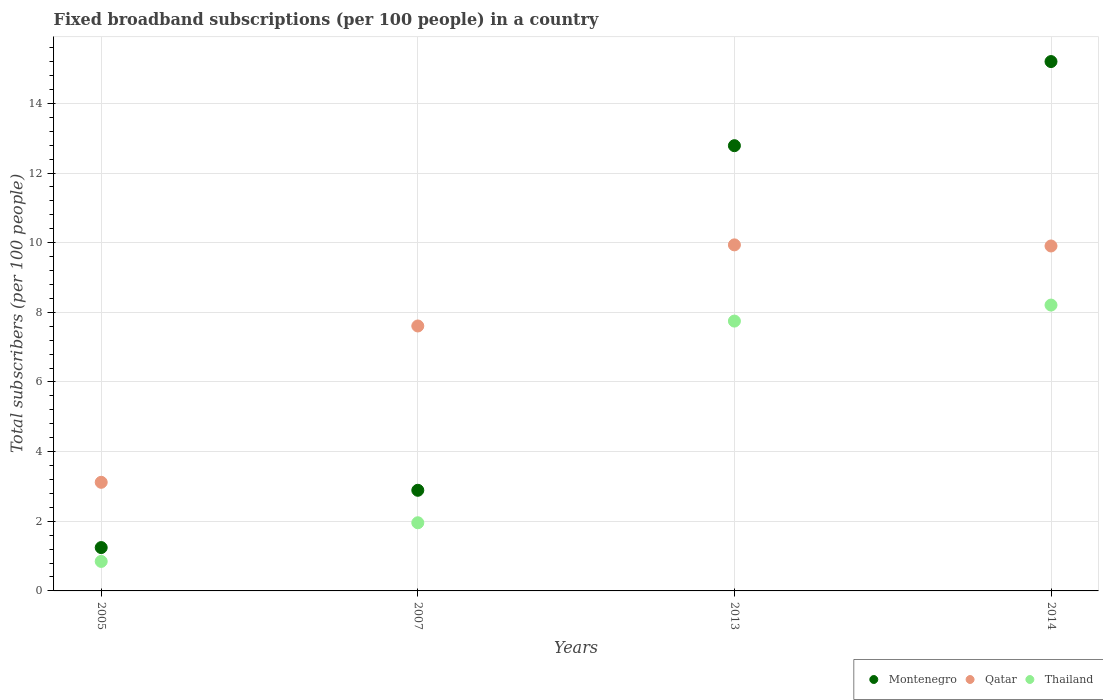How many different coloured dotlines are there?
Give a very brief answer. 3. Is the number of dotlines equal to the number of legend labels?
Provide a succinct answer. Yes. What is the number of broadband subscriptions in Montenegro in 2014?
Provide a succinct answer. 15.2. Across all years, what is the maximum number of broadband subscriptions in Qatar?
Your answer should be very brief. 9.94. Across all years, what is the minimum number of broadband subscriptions in Thailand?
Your answer should be compact. 0.85. What is the total number of broadband subscriptions in Montenegro in the graph?
Provide a short and direct response. 32.12. What is the difference between the number of broadband subscriptions in Montenegro in 2005 and that in 2014?
Give a very brief answer. -13.96. What is the difference between the number of broadband subscriptions in Montenegro in 2013 and the number of broadband subscriptions in Qatar in 2014?
Provide a short and direct response. 2.88. What is the average number of broadband subscriptions in Qatar per year?
Give a very brief answer. 7.64. In the year 2014, what is the difference between the number of broadband subscriptions in Montenegro and number of broadband subscriptions in Qatar?
Provide a succinct answer. 5.29. In how many years, is the number of broadband subscriptions in Thailand greater than 15.2?
Make the answer very short. 0. What is the ratio of the number of broadband subscriptions in Montenegro in 2007 to that in 2014?
Offer a terse response. 0.19. Is the difference between the number of broadband subscriptions in Montenegro in 2007 and 2014 greater than the difference between the number of broadband subscriptions in Qatar in 2007 and 2014?
Offer a very short reply. No. What is the difference between the highest and the second highest number of broadband subscriptions in Montenegro?
Make the answer very short. 2.42. What is the difference between the highest and the lowest number of broadband subscriptions in Thailand?
Your answer should be very brief. 7.36. In how many years, is the number of broadband subscriptions in Qatar greater than the average number of broadband subscriptions in Qatar taken over all years?
Make the answer very short. 2. Is the sum of the number of broadband subscriptions in Qatar in 2013 and 2014 greater than the maximum number of broadband subscriptions in Thailand across all years?
Provide a short and direct response. Yes. Is it the case that in every year, the sum of the number of broadband subscriptions in Qatar and number of broadband subscriptions in Thailand  is greater than the number of broadband subscriptions in Montenegro?
Offer a very short reply. Yes. Does the number of broadband subscriptions in Qatar monotonically increase over the years?
Offer a very short reply. No. Is the number of broadband subscriptions in Montenegro strictly greater than the number of broadband subscriptions in Thailand over the years?
Offer a terse response. Yes. Is the number of broadband subscriptions in Thailand strictly less than the number of broadband subscriptions in Montenegro over the years?
Provide a succinct answer. Yes. What is the difference between two consecutive major ticks on the Y-axis?
Keep it short and to the point. 2. Are the values on the major ticks of Y-axis written in scientific E-notation?
Ensure brevity in your answer.  No. Does the graph contain any zero values?
Your answer should be compact. No. Does the graph contain grids?
Provide a succinct answer. Yes. Where does the legend appear in the graph?
Keep it short and to the point. Bottom right. How many legend labels are there?
Your answer should be very brief. 3. What is the title of the graph?
Your response must be concise. Fixed broadband subscriptions (per 100 people) in a country. Does "Belize" appear as one of the legend labels in the graph?
Provide a succinct answer. No. What is the label or title of the X-axis?
Provide a short and direct response. Years. What is the label or title of the Y-axis?
Your response must be concise. Total subscribers (per 100 people). What is the Total subscribers (per 100 people) in Montenegro in 2005?
Your answer should be very brief. 1.24. What is the Total subscribers (per 100 people) in Qatar in 2005?
Ensure brevity in your answer.  3.12. What is the Total subscribers (per 100 people) in Thailand in 2005?
Offer a very short reply. 0.85. What is the Total subscribers (per 100 people) in Montenegro in 2007?
Your answer should be compact. 2.89. What is the Total subscribers (per 100 people) of Qatar in 2007?
Make the answer very short. 7.61. What is the Total subscribers (per 100 people) of Thailand in 2007?
Your response must be concise. 1.96. What is the Total subscribers (per 100 people) of Montenegro in 2013?
Make the answer very short. 12.78. What is the Total subscribers (per 100 people) of Qatar in 2013?
Give a very brief answer. 9.94. What is the Total subscribers (per 100 people) of Thailand in 2013?
Your answer should be compact. 7.75. What is the Total subscribers (per 100 people) in Montenegro in 2014?
Offer a very short reply. 15.2. What is the Total subscribers (per 100 people) in Qatar in 2014?
Keep it short and to the point. 9.9. What is the Total subscribers (per 100 people) in Thailand in 2014?
Ensure brevity in your answer.  8.21. Across all years, what is the maximum Total subscribers (per 100 people) in Montenegro?
Ensure brevity in your answer.  15.2. Across all years, what is the maximum Total subscribers (per 100 people) in Qatar?
Ensure brevity in your answer.  9.94. Across all years, what is the maximum Total subscribers (per 100 people) in Thailand?
Keep it short and to the point. 8.21. Across all years, what is the minimum Total subscribers (per 100 people) in Montenegro?
Make the answer very short. 1.24. Across all years, what is the minimum Total subscribers (per 100 people) of Qatar?
Keep it short and to the point. 3.12. Across all years, what is the minimum Total subscribers (per 100 people) of Thailand?
Provide a succinct answer. 0.85. What is the total Total subscribers (per 100 people) of Montenegro in the graph?
Your answer should be very brief. 32.12. What is the total Total subscribers (per 100 people) in Qatar in the graph?
Keep it short and to the point. 30.57. What is the total Total subscribers (per 100 people) in Thailand in the graph?
Give a very brief answer. 18.76. What is the difference between the Total subscribers (per 100 people) in Montenegro in 2005 and that in 2007?
Make the answer very short. -1.64. What is the difference between the Total subscribers (per 100 people) of Qatar in 2005 and that in 2007?
Provide a short and direct response. -4.49. What is the difference between the Total subscribers (per 100 people) in Thailand in 2005 and that in 2007?
Keep it short and to the point. -1.11. What is the difference between the Total subscribers (per 100 people) of Montenegro in 2005 and that in 2013?
Provide a short and direct response. -11.54. What is the difference between the Total subscribers (per 100 people) in Qatar in 2005 and that in 2013?
Provide a short and direct response. -6.82. What is the difference between the Total subscribers (per 100 people) in Thailand in 2005 and that in 2013?
Give a very brief answer. -6.9. What is the difference between the Total subscribers (per 100 people) in Montenegro in 2005 and that in 2014?
Make the answer very short. -13.96. What is the difference between the Total subscribers (per 100 people) of Qatar in 2005 and that in 2014?
Provide a succinct answer. -6.79. What is the difference between the Total subscribers (per 100 people) of Thailand in 2005 and that in 2014?
Provide a short and direct response. -7.36. What is the difference between the Total subscribers (per 100 people) of Montenegro in 2007 and that in 2013?
Your response must be concise. -9.89. What is the difference between the Total subscribers (per 100 people) of Qatar in 2007 and that in 2013?
Your answer should be very brief. -2.33. What is the difference between the Total subscribers (per 100 people) of Thailand in 2007 and that in 2013?
Ensure brevity in your answer.  -5.79. What is the difference between the Total subscribers (per 100 people) of Montenegro in 2007 and that in 2014?
Offer a very short reply. -12.31. What is the difference between the Total subscribers (per 100 people) of Qatar in 2007 and that in 2014?
Your response must be concise. -2.3. What is the difference between the Total subscribers (per 100 people) in Thailand in 2007 and that in 2014?
Keep it short and to the point. -6.25. What is the difference between the Total subscribers (per 100 people) of Montenegro in 2013 and that in 2014?
Give a very brief answer. -2.42. What is the difference between the Total subscribers (per 100 people) of Qatar in 2013 and that in 2014?
Your response must be concise. 0.03. What is the difference between the Total subscribers (per 100 people) of Thailand in 2013 and that in 2014?
Your response must be concise. -0.46. What is the difference between the Total subscribers (per 100 people) of Montenegro in 2005 and the Total subscribers (per 100 people) of Qatar in 2007?
Your response must be concise. -6.36. What is the difference between the Total subscribers (per 100 people) in Montenegro in 2005 and the Total subscribers (per 100 people) in Thailand in 2007?
Offer a terse response. -0.71. What is the difference between the Total subscribers (per 100 people) of Qatar in 2005 and the Total subscribers (per 100 people) of Thailand in 2007?
Ensure brevity in your answer.  1.16. What is the difference between the Total subscribers (per 100 people) of Montenegro in 2005 and the Total subscribers (per 100 people) of Qatar in 2013?
Ensure brevity in your answer.  -8.69. What is the difference between the Total subscribers (per 100 people) of Montenegro in 2005 and the Total subscribers (per 100 people) of Thailand in 2013?
Your response must be concise. -6.5. What is the difference between the Total subscribers (per 100 people) in Qatar in 2005 and the Total subscribers (per 100 people) in Thailand in 2013?
Make the answer very short. -4.63. What is the difference between the Total subscribers (per 100 people) in Montenegro in 2005 and the Total subscribers (per 100 people) in Qatar in 2014?
Give a very brief answer. -8.66. What is the difference between the Total subscribers (per 100 people) of Montenegro in 2005 and the Total subscribers (per 100 people) of Thailand in 2014?
Ensure brevity in your answer.  -6.96. What is the difference between the Total subscribers (per 100 people) of Qatar in 2005 and the Total subscribers (per 100 people) of Thailand in 2014?
Make the answer very short. -5.09. What is the difference between the Total subscribers (per 100 people) in Montenegro in 2007 and the Total subscribers (per 100 people) in Qatar in 2013?
Keep it short and to the point. -7.05. What is the difference between the Total subscribers (per 100 people) of Montenegro in 2007 and the Total subscribers (per 100 people) of Thailand in 2013?
Offer a very short reply. -4.86. What is the difference between the Total subscribers (per 100 people) in Qatar in 2007 and the Total subscribers (per 100 people) in Thailand in 2013?
Offer a very short reply. -0.14. What is the difference between the Total subscribers (per 100 people) of Montenegro in 2007 and the Total subscribers (per 100 people) of Qatar in 2014?
Offer a very short reply. -7.02. What is the difference between the Total subscribers (per 100 people) of Montenegro in 2007 and the Total subscribers (per 100 people) of Thailand in 2014?
Make the answer very short. -5.32. What is the difference between the Total subscribers (per 100 people) of Qatar in 2007 and the Total subscribers (per 100 people) of Thailand in 2014?
Offer a very short reply. -0.6. What is the difference between the Total subscribers (per 100 people) of Montenegro in 2013 and the Total subscribers (per 100 people) of Qatar in 2014?
Offer a very short reply. 2.88. What is the difference between the Total subscribers (per 100 people) of Montenegro in 2013 and the Total subscribers (per 100 people) of Thailand in 2014?
Your answer should be compact. 4.58. What is the difference between the Total subscribers (per 100 people) in Qatar in 2013 and the Total subscribers (per 100 people) in Thailand in 2014?
Ensure brevity in your answer.  1.73. What is the average Total subscribers (per 100 people) in Montenegro per year?
Keep it short and to the point. 8.03. What is the average Total subscribers (per 100 people) in Qatar per year?
Offer a terse response. 7.64. What is the average Total subscribers (per 100 people) of Thailand per year?
Make the answer very short. 4.69. In the year 2005, what is the difference between the Total subscribers (per 100 people) of Montenegro and Total subscribers (per 100 people) of Qatar?
Your answer should be very brief. -1.87. In the year 2005, what is the difference between the Total subscribers (per 100 people) of Montenegro and Total subscribers (per 100 people) of Thailand?
Ensure brevity in your answer.  0.4. In the year 2005, what is the difference between the Total subscribers (per 100 people) in Qatar and Total subscribers (per 100 people) in Thailand?
Provide a succinct answer. 2.27. In the year 2007, what is the difference between the Total subscribers (per 100 people) of Montenegro and Total subscribers (per 100 people) of Qatar?
Ensure brevity in your answer.  -4.72. In the year 2007, what is the difference between the Total subscribers (per 100 people) in Montenegro and Total subscribers (per 100 people) in Thailand?
Provide a succinct answer. 0.93. In the year 2007, what is the difference between the Total subscribers (per 100 people) of Qatar and Total subscribers (per 100 people) of Thailand?
Your answer should be compact. 5.65. In the year 2013, what is the difference between the Total subscribers (per 100 people) in Montenegro and Total subscribers (per 100 people) in Qatar?
Provide a short and direct response. 2.85. In the year 2013, what is the difference between the Total subscribers (per 100 people) of Montenegro and Total subscribers (per 100 people) of Thailand?
Keep it short and to the point. 5.04. In the year 2013, what is the difference between the Total subscribers (per 100 people) of Qatar and Total subscribers (per 100 people) of Thailand?
Offer a very short reply. 2.19. In the year 2014, what is the difference between the Total subscribers (per 100 people) of Montenegro and Total subscribers (per 100 people) of Qatar?
Provide a succinct answer. 5.29. In the year 2014, what is the difference between the Total subscribers (per 100 people) in Montenegro and Total subscribers (per 100 people) in Thailand?
Your answer should be compact. 6.99. In the year 2014, what is the difference between the Total subscribers (per 100 people) of Qatar and Total subscribers (per 100 people) of Thailand?
Offer a terse response. 1.7. What is the ratio of the Total subscribers (per 100 people) in Montenegro in 2005 to that in 2007?
Keep it short and to the point. 0.43. What is the ratio of the Total subscribers (per 100 people) of Qatar in 2005 to that in 2007?
Make the answer very short. 0.41. What is the ratio of the Total subscribers (per 100 people) of Thailand in 2005 to that in 2007?
Offer a terse response. 0.43. What is the ratio of the Total subscribers (per 100 people) of Montenegro in 2005 to that in 2013?
Provide a succinct answer. 0.1. What is the ratio of the Total subscribers (per 100 people) of Qatar in 2005 to that in 2013?
Offer a terse response. 0.31. What is the ratio of the Total subscribers (per 100 people) in Thailand in 2005 to that in 2013?
Your answer should be very brief. 0.11. What is the ratio of the Total subscribers (per 100 people) in Montenegro in 2005 to that in 2014?
Offer a terse response. 0.08. What is the ratio of the Total subscribers (per 100 people) in Qatar in 2005 to that in 2014?
Your response must be concise. 0.31. What is the ratio of the Total subscribers (per 100 people) in Thailand in 2005 to that in 2014?
Make the answer very short. 0.1. What is the ratio of the Total subscribers (per 100 people) in Montenegro in 2007 to that in 2013?
Provide a short and direct response. 0.23. What is the ratio of the Total subscribers (per 100 people) of Qatar in 2007 to that in 2013?
Provide a succinct answer. 0.77. What is the ratio of the Total subscribers (per 100 people) in Thailand in 2007 to that in 2013?
Your answer should be compact. 0.25. What is the ratio of the Total subscribers (per 100 people) of Montenegro in 2007 to that in 2014?
Provide a succinct answer. 0.19. What is the ratio of the Total subscribers (per 100 people) in Qatar in 2007 to that in 2014?
Offer a terse response. 0.77. What is the ratio of the Total subscribers (per 100 people) of Thailand in 2007 to that in 2014?
Provide a succinct answer. 0.24. What is the ratio of the Total subscribers (per 100 people) in Montenegro in 2013 to that in 2014?
Provide a succinct answer. 0.84. What is the ratio of the Total subscribers (per 100 people) in Thailand in 2013 to that in 2014?
Your answer should be very brief. 0.94. What is the difference between the highest and the second highest Total subscribers (per 100 people) in Montenegro?
Provide a short and direct response. 2.42. What is the difference between the highest and the second highest Total subscribers (per 100 people) in Qatar?
Your answer should be very brief. 0.03. What is the difference between the highest and the second highest Total subscribers (per 100 people) of Thailand?
Give a very brief answer. 0.46. What is the difference between the highest and the lowest Total subscribers (per 100 people) in Montenegro?
Your answer should be very brief. 13.96. What is the difference between the highest and the lowest Total subscribers (per 100 people) of Qatar?
Make the answer very short. 6.82. What is the difference between the highest and the lowest Total subscribers (per 100 people) in Thailand?
Your answer should be compact. 7.36. 